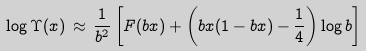<formula> <loc_0><loc_0><loc_500><loc_500>\log \Upsilon ( x ) \, \approx \, \frac { 1 } { b ^ { 2 } } \left [ F ( b x ) + \left ( b x ( 1 - b x ) - \frac { 1 } { 4 } \right ) \log b \right ]</formula> 